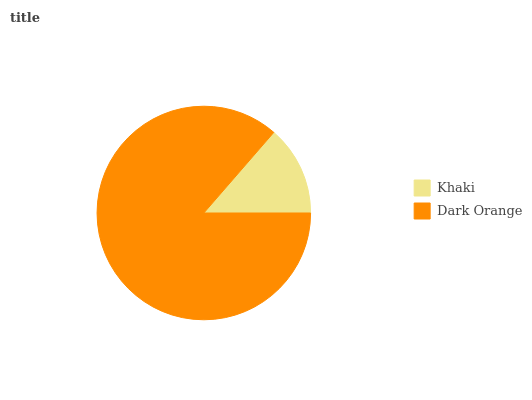Is Khaki the minimum?
Answer yes or no. Yes. Is Dark Orange the maximum?
Answer yes or no. Yes. Is Dark Orange the minimum?
Answer yes or no. No. Is Dark Orange greater than Khaki?
Answer yes or no. Yes. Is Khaki less than Dark Orange?
Answer yes or no. Yes. Is Khaki greater than Dark Orange?
Answer yes or no. No. Is Dark Orange less than Khaki?
Answer yes or no. No. Is Dark Orange the high median?
Answer yes or no. Yes. Is Khaki the low median?
Answer yes or no. Yes. Is Khaki the high median?
Answer yes or no. No. Is Dark Orange the low median?
Answer yes or no. No. 